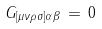Convert formula to latex. <formula><loc_0><loc_0><loc_500><loc_500>G _ { [ \mu \nu \rho \sigma ] \alpha \beta } \, = \, 0</formula> 